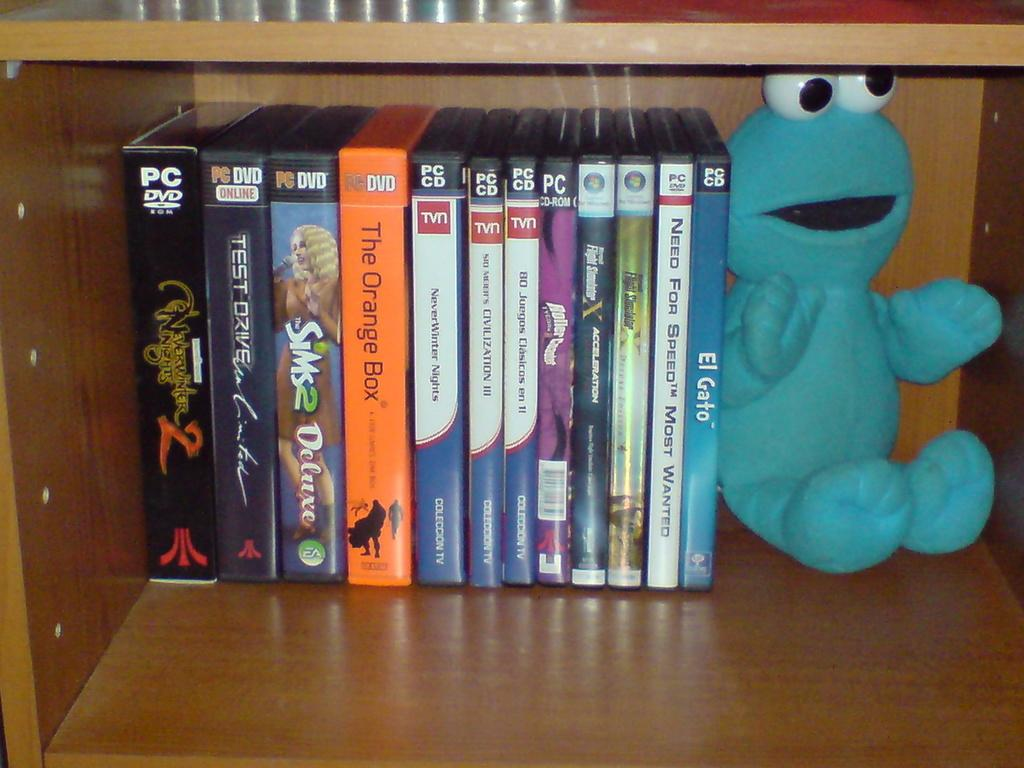<image>
Write a terse but informative summary of the picture. A row of PC game boxes that includes SIMS and Civilization III next to a blue stuffed animal 